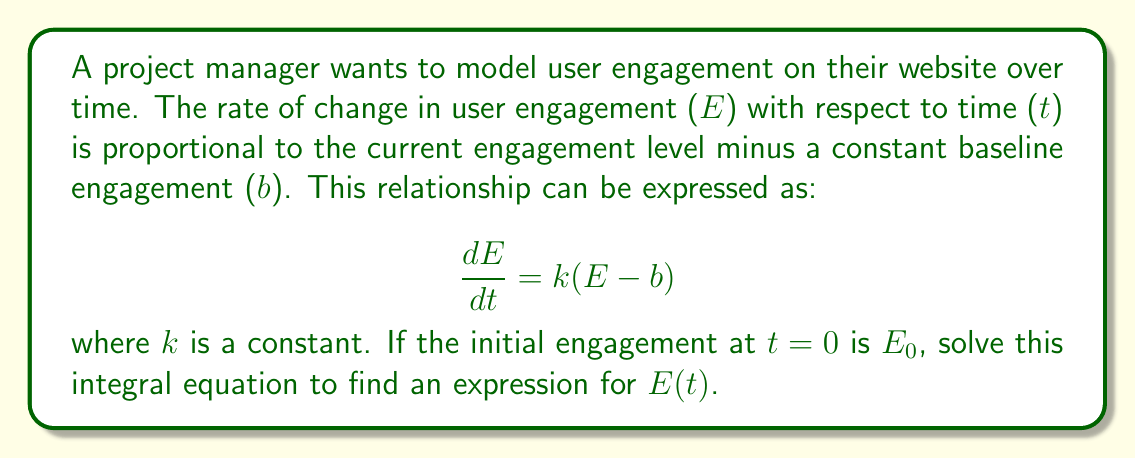Solve this math problem. Let's solve this integral equation step by step:

1) First, rearrange the equation to separate variables:
   $$\frac{dE}{E - b} = k dt$$

2) Integrate both sides:
   $$\int \frac{dE}{E - b} = \int k dt$$

3) The left side integrates to ln|E - b|, and the right side to kt + C:
   $$\ln|E - b| = kt + C$$

4) Exponentiate both sides:
   $$e^{\ln|E - b|} = e^{kt + C}$$
   $$|E - b| = e^{kt} \cdot e^C$$

5) Let A = e^C (a positive constant), then:
   $$E - b = Ae^{kt}$$

6) Solve for E:
   $$E = Ae^{kt} + b$$

7) To find A, use the initial condition E(0) = E₀:
   $$E₀ = Ae^{k(0)} + b$$
   $$E₀ = A + b$$
   $$A = E₀ - b$$

8) Substitute this back into the equation for E:
   $$E = (E₀ - b)e^{kt} + b$$

This is the final solution for E(t).
Answer: $E = (E₀ - b)e^{kt} + b$ 